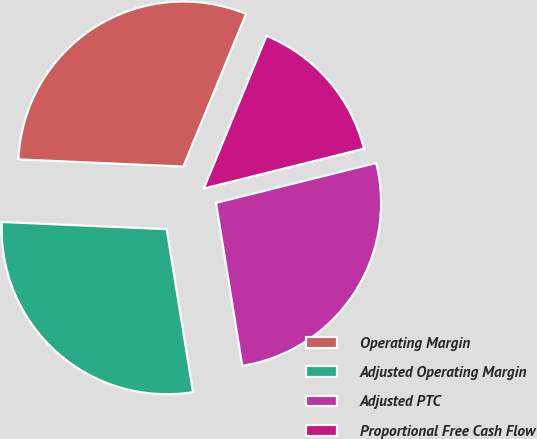Convert chart to OTSL. <chart><loc_0><loc_0><loc_500><loc_500><pie_chart><fcel>Operating Margin<fcel>Adjusted Operating Margin<fcel>Adjusted PTC<fcel>Proportional Free Cash Flow<nl><fcel>30.51%<fcel>28.24%<fcel>26.34%<fcel>14.91%<nl></chart> 